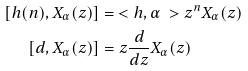<formula> <loc_0><loc_0><loc_500><loc_500>[ h ( n ) , X _ { \alpha } ( z ) ] & = \ < h , \alpha \ > z ^ { n } X _ { \alpha } ( z ) \\ [ d , X _ { \alpha } ( z ) ] & = z \frac { d } { d z } X _ { \alpha } ( z )</formula> 